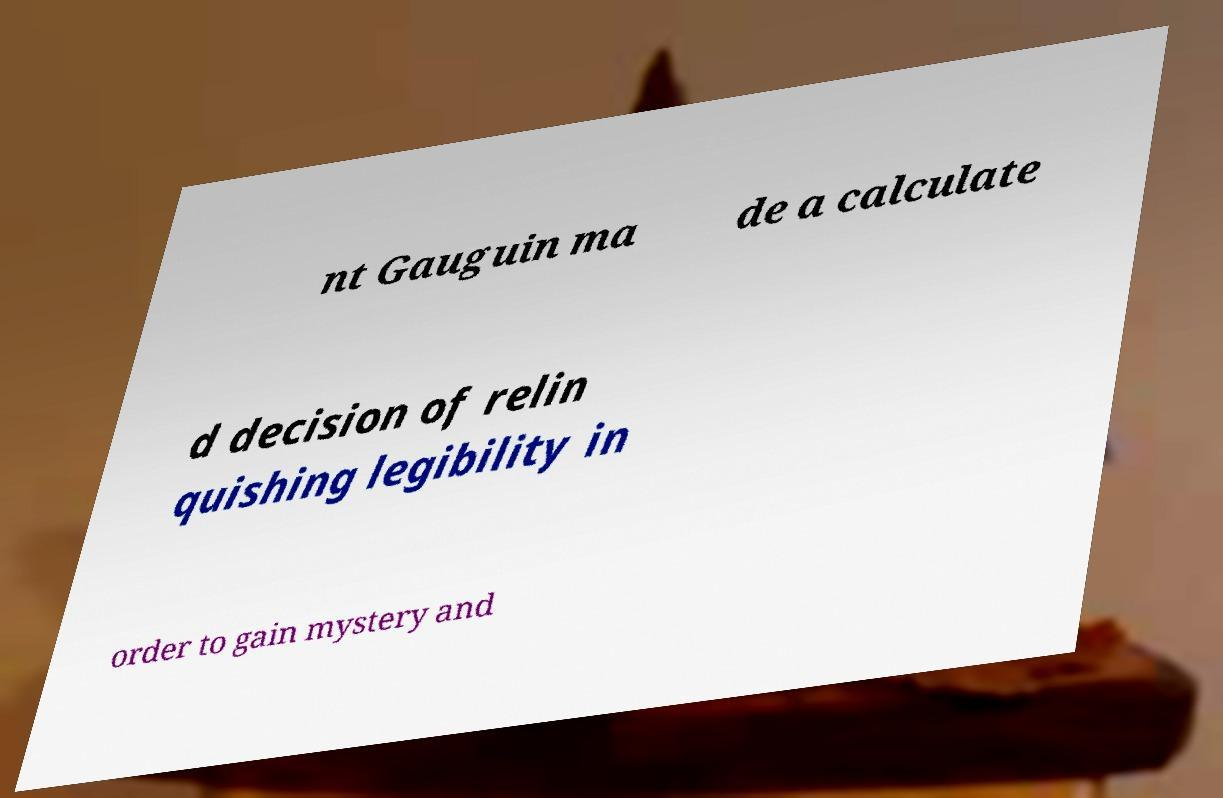What messages or text are displayed in this image? I need them in a readable, typed format. nt Gauguin ma de a calculate d decision of relin quishing legibility in order to gain mystery and 